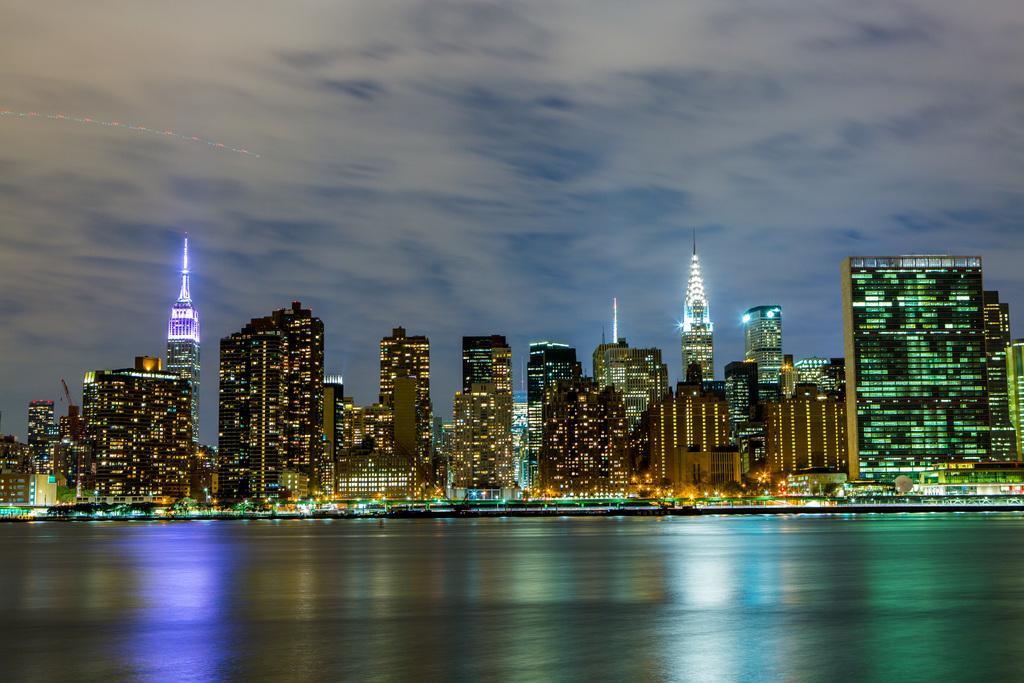In one or two sentences, can you explain what this image depicts? In this picture I can see there is a sea and there are few buildings in the backdrop, they have glass windows and the light is visible from the window. There are two towers and the lights are arranged at the top of them and the sky is clear. 